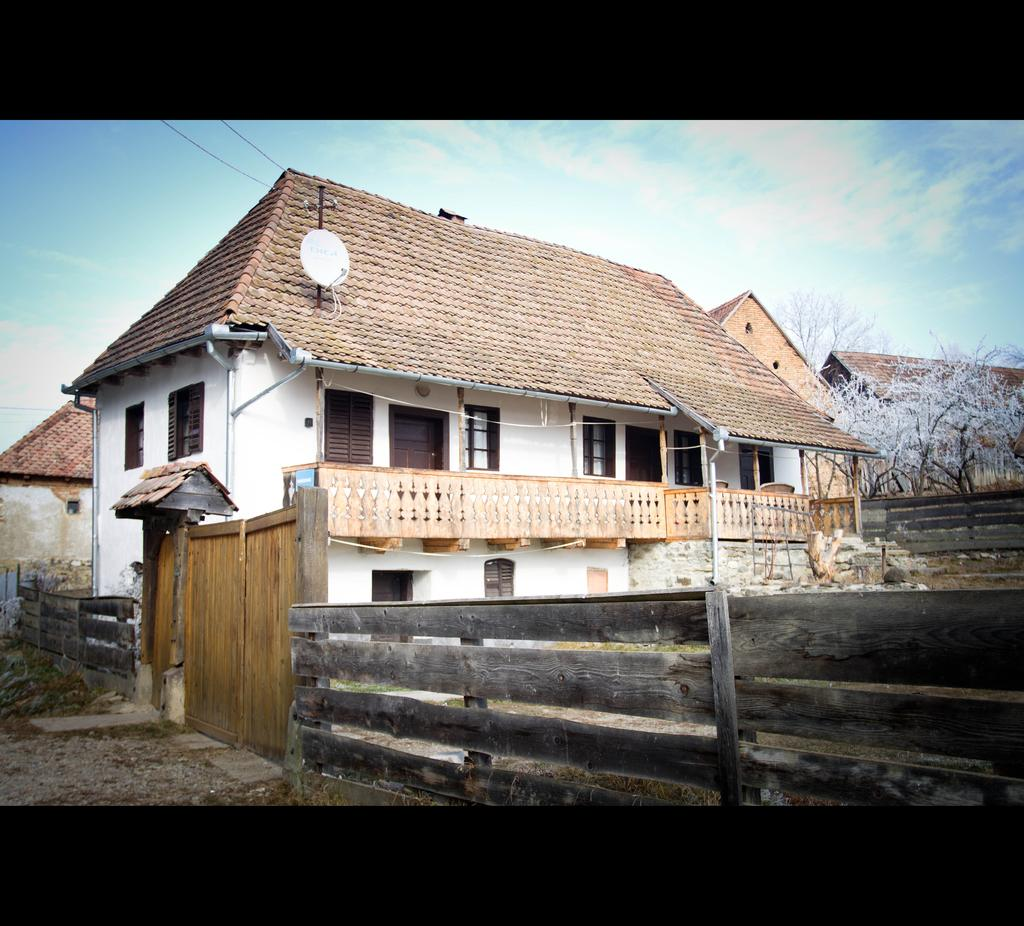What type of fencing is present in the image? There is wooden fencing in the image. What structures can be seen in the image? There are houses in the image. What type of vegetation is present in the image? There are trees in the image. What is visible in the background of the image? The sky is visible in the image. How many geese are flying in the sky in the image? There are no geese present in the image; only wooden fencing, houses, trees, and the sky are visible. What type of quiver is attached to the tree in the image? There is no quiver present in the image; it features wooden fencing, houses, trees, and the sky. 